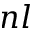<formula> <loc_0><loc_0><loc_500><loc_500>n l</formula> 